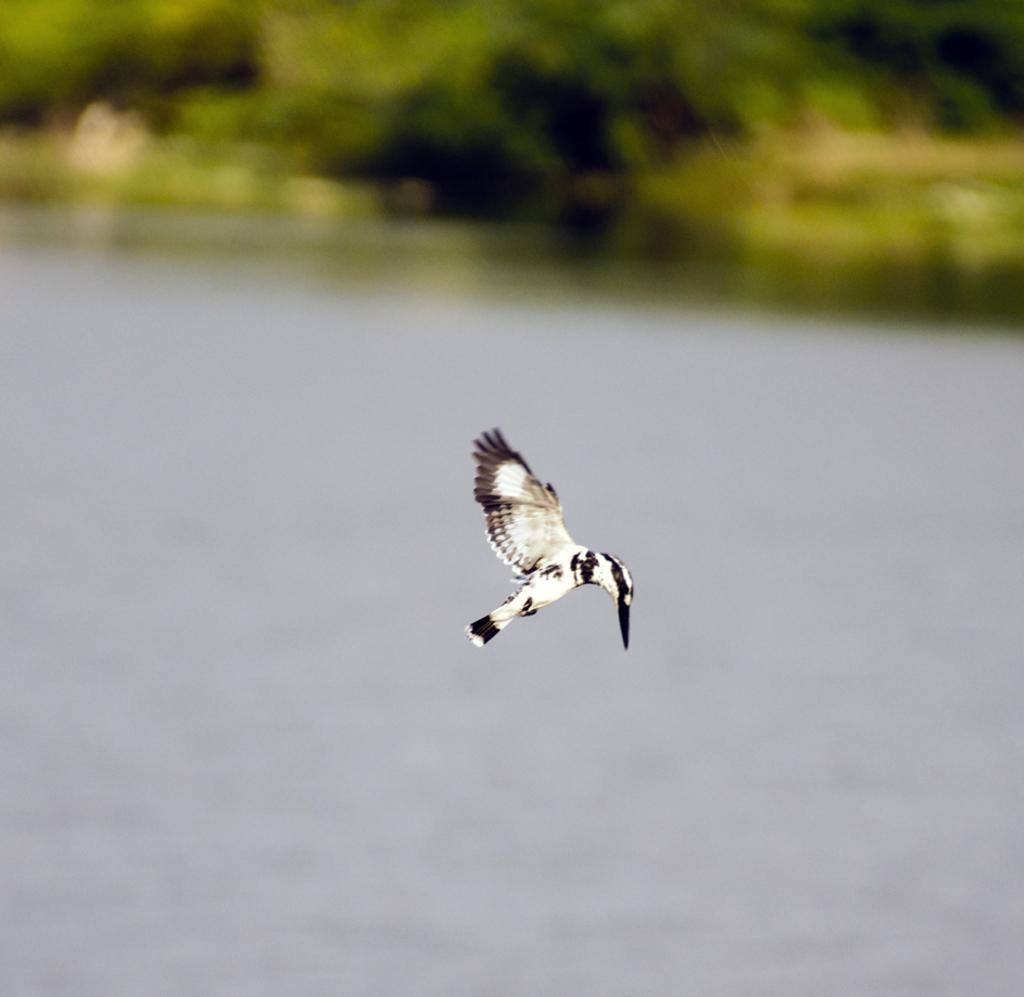What type of animal can be seen in the image? There is a bird in the image. What is the bird doing in the image? The bird is flying above the water. What can be seen in the background of the image? There are trees in the background of the image. What type of body of water is the bird flying over in the image? The provided facts do not specify the type of body of water, so it cannot be determined from the image. Is there a quiver present in the image? There is no mention of a quiver in the provided facts, and therefore it cannot be determined if one is present in the image. 